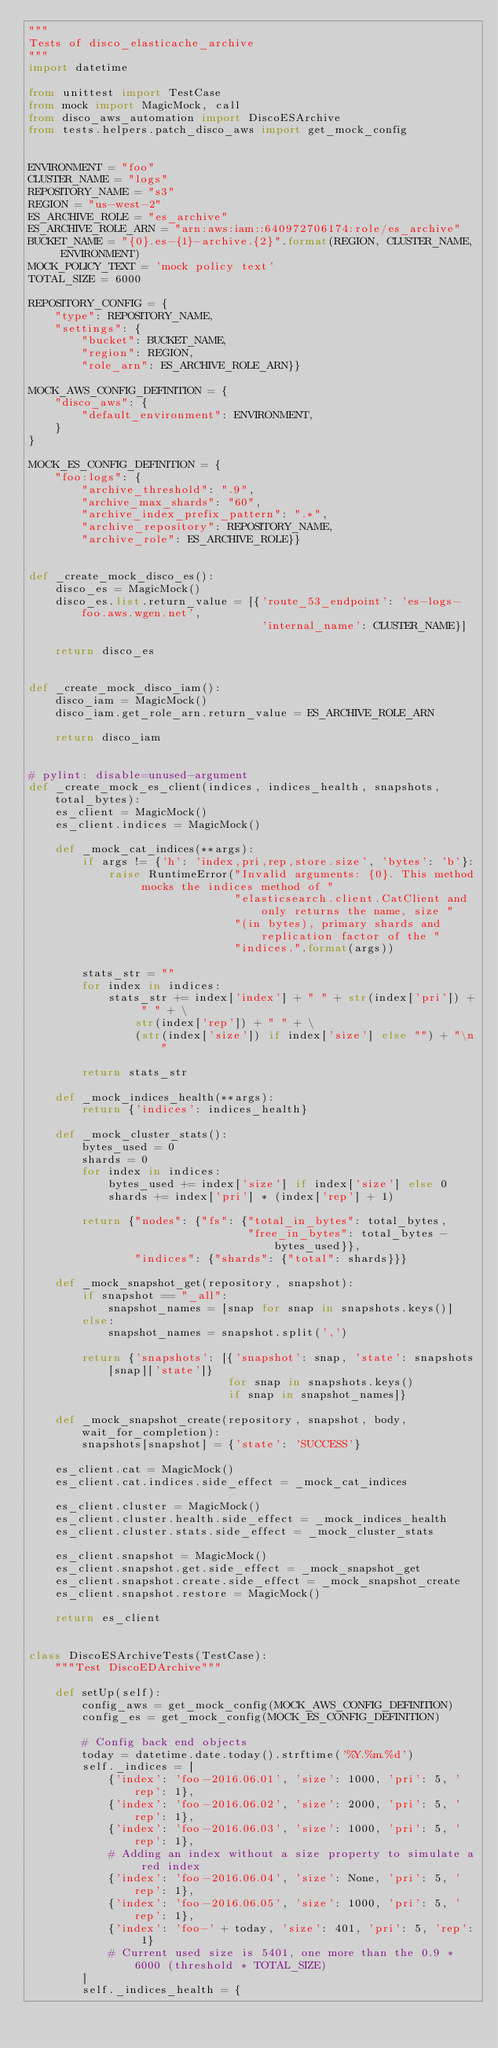Convert code to text. <code><loc_0><loc_0><loc_500><loc_500><_Python_>"""
Tests of disco_elasticache_archive
"""
import datetime

from unittest import TestCase
from mock import MagicMock, call
from disco_aws_automation import DiscoESArchive
from tests.helpers.patch_disco_aws import get_mock_config


ENVIRONMENT = "foo"
CLUSTER_NAME = "logs"
REPOSITORY_NAME = "s3"
REGION = "us-west-2"
ES_ARCHIVE_ROLE = "es_archive"
ES_ARCHIVE_ROLE_ARN = "arn:aws:iam::640972706174:role/es_archive"
BUCKET_NAME = "{0}.es-{1}-archive.{2}".format(REGION, CLUSTER_NAME, ENVIRONMENT)
MOCK_POLICY_TEXT = 'mock policy text'
TOTAL_SIZE = 6000

REPOSITORY_CONFIG = {
    "type": REPOSITORY_NAME,
    "settings": {
        "bucket": BUCKET_NAME,
        "region": REGION,
        "role_arn": ES_ARCHIVE_ROLE_ARN}}

MOCK_AWS_CONFIG_DEFINITION = {
    "disco_aws": {
        "default_environment": ENVIRONMENT,
    }
}

MOCK_ES_CONFIG_DEFINITION = {
    "foo:logs": {
        "archive_threshold": ".9",
        "archive_max_shards": "60",
        "archive_index_prefix_pattern": ".*",
        "archive_repository": REPOSITORY_NAME,
        "archive_role": ES_ARCHIVE_ROLE}}


def _create_mock_disco_es():
    disco_es = MagicMock()
    disco_es.list.return_value = [{'route_53_endpoint': 'es-logs-foo.aws.wgen.net',
                                   'internal_name': CLUSTER_NAME}]

    return disco_es


def _create_mock_disco_iam():
    disco_iam = MagicMock()
    disco_iam.get_role_arn.return_value = ES_ARCHIVE_ROLE_ARN

    return disco_iam


# pylint: disable=unused-argument
def _create_mock_es_client(indices, indices_health, snapshots, total_bytes):
    es_client = MagicMock()
    es_client.indices = MagicMock()

    def _mock_cat_indices(**args):
        if args != {'h': 'index,pri,rep,store.size', 'bytes': 'b'}:
            raise RuntimeError("Invalid arguments: {0}. This method mocks the indices method of "
                               "elasticsearch.client.CatClient and only returns the name, size "
                               "(in bytes), primary shards and replication factor of the "
                               "indices.".format(args))

        stats_str = ""
        for index in indices:
            stats_str += index['index'] + " " + str(index['pri']) + " " + \
                str(index['rep']) + " " + \
                (str(index['size']) if index['size'] else "") + "\n"

        return stats_str

    def _mock_indices_health(**args):
        return {'indices': indices_health}

    def _mock_cluster_stats():
        bytes_used = 0
        shards = 0
        for index in indices:
            bytes_used += index['size'] if index['size'] else 0
            shards += index['pri'] * (index['rep'] + 1)

        return {"nodes": {"fs": {"total_in_bytes": total_bytes,
                                 "free_in_bytes": total_bytes - bytes_used}},
                "indices": {"shards": {"total": shards}}}

    def _mock_snapshot_get(repository, snapshot):
        if snapshot == "_all":
            snapshot_names = [snap for snap in snapshots.keys()]
        else:
            snapshot_names = snapshot.split(',')

        return {'snapshots': [{'snapshot': snap, 'state': snapshots[snap]['state']}
                              for snap in snapshots.keys()
                              if snap in snapshot_names]}

    def _mock_snapshot_create(repository, snapshot, body, wait_for_completion):
        snapshots[snapshot] = {'state': 'SUCCESS'}

    es_client.cat = MagicMock()
    es_client.cat.indices.side_effect = _mock_cat_indices

    es_client.cluster = MagicMock()
    es_client.cluster.health.side_effect = _mock_indices_health
    es_client.cluster.stats.side_effect = _mock_cluster_stats

    es_client.snapshot = MagicMock()
    es_client.snapshot.get.side_effect = _mock_snapshot_get
    es_client.snapshot.create.side_effect = _mock_snapshot_create
    es_client.snapshot.restore = MagicMock()

    return es_client


class DiscoESArchiveTests(TestCase):
    """Test DiscoEDArchive"""

    def setUp(self):
        config_aws = get_mock_config(MOCK_AWS_CONFIG_DEFINITION)
        config_es = get_mock_config(MOCK_ES_CONFIG_DEFINITION)

        # Config back end objects
        today = datetime.date.today().strftime('%Y.%m.%d')
        self._indices = [
            {'index': 'foo-2016.06.01', 'size': 1000, 'pri': 5, 'rep': 1},
            {'index': 'foo-2016.06.02', 'size': 2000, 'pri': 5, 'rep': 1},
            {'index': 'foo-2016.06.03', 'size': 1000, 'pri': 5, 'rep': 1},
            # Adding an index without a size property to simulate a red index
            {'index': 'foo-2016.06.04', 'size': None, 'pri': 5, 'rep': 1},
            {'index': 'foo-2016.06.05', 'size': 1000, 'pri': 5, 'rep': 1},
            {'index': 'foo-' + today, 'size': 401, 'pri': 5, 'rep': 1}
            # Current used size is 5401, one more than the 0.9 * 6000 (threshold * TOTAL_SIZE)
        ]
        self._indices_health = {</code> 